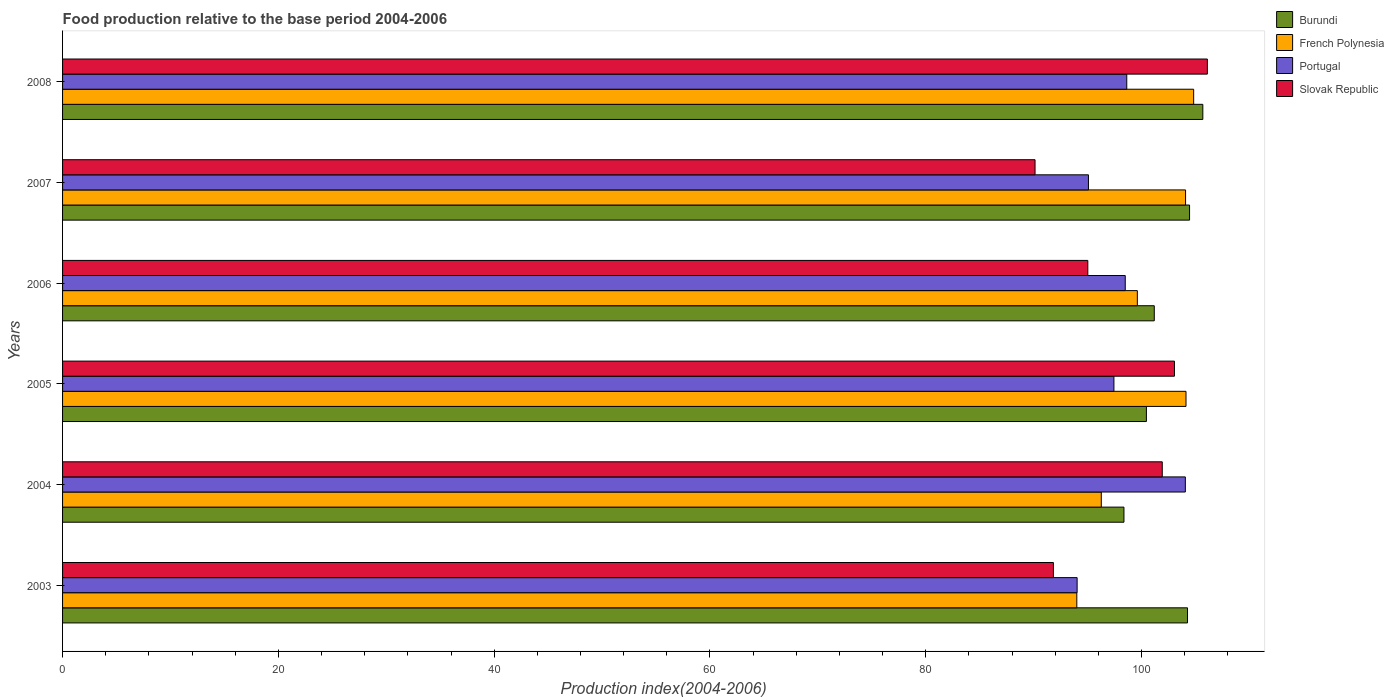Are the number of bars on each tick of the Y-axis equal?
Offer a very short reply. Yes. What is the food production index in Burundi in 2003?
Keep it short and to the point. 104.26. Across all years, what is the maximum food production index in Burundi?
Provide a short and direct response. 105.68. Across all years, what is the minimum food production index in French Polynesia?
Your answer should be very brief. 94. In which year was the food production index in Slovak Republic minimum?
Provide a succinct answer. 2007. What is the total food production index in Burundi in the graph?
Provide a short and direct response. 614.39. What is the difference between the food production index in Slovak Republic in 2004 and that in 2007?
Make the answer very short. 11.79. What is the difference between the food production index in Portugal in 2005 and the food production index in Slovak Republic in 2007?
Your answer should be very brief. 7.31. What is the average food production index in Slovak Republic per year?
Keep it short and to the point. 98.01. In the year 2007, what is the difference between the food production index in French Polynesia and food production index in Burundi?
Offer a very short reply. -0.37. In how many years, is the food production index in French Polynesia greater than 32 ?
Make the answer very short. 6. What is the ratio of the food production index in French Polynesia in 2004 to that in 2007?
Offer a very short reply. 0.92. Is the difference between the food production index in French Polynesia in 2007 and 2008 greater than the difference between the food production index in Burundi in 2007 and 2008?
Your response must be concise. Yes. What is the difference between the highest and the second highest food production index in Slovak Republic?
Your answer should be compact. 3.05. What is the difference between the highest and the lowest food production index in Slovak Republic?
Make the answer very short. 15.97. Is the sum of the food production index in Portugal in 2005 and 2008 greater than the maximum food production index in French Polynesia across all years?
Offer a terse response. Yes. What does the 3rd bar from the top in 2003 represents?
Keep it short and to the point. French Polynesia. What does the 4th bar from the bottom in 2008 represents?
Offer a very short reply. Slovak Republic. Are all the bars in the graph horizontal?
Make the answer very short. Yes. How many years are there in the graph?
Your answer should be compact. 6. What is the difference between two consecutive major ticks on the X-axis?
Your answer should be very brief. 20. Does the graph contain grids?
Your answer should be very brief. No. Where does the legend appear in the graph?
Offer a terse response. Top right. How many legend labels are there?
Your answer should be compact. 4. What is the title of the graph?
Your answer should be very brief. Food production relative to the base period 2004-2006. Does "Australia" appear as one of the legend labels in the graph?
Ensure brevity in your answer.  No. What is the label or title of the X-axis?
Your response must be concise. Production index(2004-2006). What is the Production index(2004-2006) of Burundi in 2003?
Your answer should be compact. 104.26. What is the Production index(2004-2006) of French Polynesia in 2003?
Offer a very short reply. 94. What is the Production index(2004-2006) in Portugal in 2003?
Provide a succinct answer. 94.03. What is the Production index(2004-2006) in Slovak Republic in 2003?
Your answer should be very brief. 91.83. What is the Production index(2004-2006) in Burundi in 2004?
Offer a very short reply. 98.37. What is the Production index(2004-2006) of French Polynesia in 2004?
Provide a succinct answer. 96.27. What is the Production index(2004-2006) in Portugal in 2004?
Make the answer very short. 104.06. What is the Production index(2004-2006) of Slovak Republic in 2004?
Your answer should be very brief. 101.92. What is the Production index(2004-2006) in Burundi in 2005?
Make the answer very short. 100.45. What is the Production index(2004-2006) of French Polynesia in 2005?
Make the answer very short. 104.12. What is the Production index(2004-2006) of Portugal in 2005?
Make the answer very short. 97.44. What is the Production index(2004-2006) in Slovak Republic in 2005?
Your answer should be compact. 103.05. What is the Production index(2004-2006) of Burundi in 2006?
Your answer should be compact. 101.18. What is the Production index(2004-2006) in French Polynesia in 2006?
Offer a very short reply. 99.61. What is the Production index(2004-2006) in Portugal in 2006?
Make the answer very short. 98.49. What is the Production index(2004-2006) of Slovak Republic in 2006?
Offer a terse response. 95.02. What is the Production index(2004-2006) of Burundi in 2007?
Give a very brief answer. 104.45. What is the Production index(2004-2006) in French Polynesia in 2007?
Provide a succinct answer. 104.08. What is the Production index(2004-2006) in Portugal in 2007?
Provide a short and direct response. 95.08. What is the Production index(2004-2006) of Slovak Republic in 2007?
Your answer should be very brief. 90.13. What is the Production index(2004-2006) of Burundi in 2008?
Give a very brief answer. 105.68. What is the Production index(2004-2006) in French Polynesia in 2008?
Offer a very short reply. 104.83. What is the Production index(2004-2006) of Portugal in 2008?
Keep it short and to the point. 98.63. What is the Production index(2004-2006) of Slovak Republic in 2008?
Offer a very short reply. 106.1. Across all years, what is the maximum Production index(2004-2006) in Burundi?
Give a very brief answer. 105.68. Across all years, what is the maximum Production index(2004-2006) in French Polynesia?
Give a very brief answer. 104.83. Across all years, what is the maximum Production index(2004-2006) in Portugal?
Provide a succinct answer. 104.06. Across all years, what is the maximum Production index(2004-2006) of Slovak Republic?
Your answer should be very brief. 106.1. Across all years, what is the minimum Production index(2004-2006) of Burundi?
Keep it short and to the point. 98.37. Across all years, what is the minimum Production index(2004-2006) of French Polynesia?
Provide a short and direct response. 94. Across all years, what is the minimum Production index(2004-2006) of Portugal?
Your answer should be very brief. 94.03. Across all years, what is the minimum Production index(2004-2006) of Slovak Republic?
Your answer should be compact. 90.13. What is the total Production index(2004-2006) in Burundi in the graph?
Your answer should be compact. 614.39. What is the total Production index(2004-2006) of French Polynesia in the graph?
Provide a short and direct response. 602.91. What is the total Production index(2004-2006) of Portugal in the graph?
Ensure brevity in your answer.  587.73. What is the total Production index(2004-2006) in Slovak Republic in the graph?
Offer a very short reply. 588.05. What is the difference between the Production index(2004-2006) in Burundi in 2003 and that in 2004?
Ensure brevity in your answer.  5.89. What is the difference between the Production index(2004-2006) of French Polynesia in 2003 and that in 2004?
Give a very brief answer. -2.27. What is the difference between the Production index(2004-2006) of Portugal in 2003 and that in 2004?
Ensure brevity in your answer.  -10.03. What is the difference between the Production index(2004-2006) in Slovak Republic in 2003 and that in 2004?
Ensure brevity in your answer.  -10.09. What is the difference between the Production index(2004-2006) in Burundi in 2003 and that in 2005?
Ensure brevity in your answer.  3.81. What is the difference between the Production index(2004-2006) of French Polynesia in 2003 and that in 2005?
Provide a short and direct response. -10.12. What is the difference between the Production index(2004-2006) in Portugal in 2003 and that in 2005?
Provide a short and direct response. -3.41. What is the difference between the Production index(2004-2006) of Slovak Republic in 2003 and that in 2005?
Your answer should be compact. -11.22. What is the difference between the Production index(2004-2006) in Burundi in 2003 and that in 2006?
Your answer should be compact. 3.08. What is the difference between the Production index(2004-2006) of French Polynesia in 2003 and that in 2006?
Provide a short and direct response. -5.61. What is the difference between the Production index(2004-2006) in Portugal in 2003 and that in 2006?
Your answer should be very brief. -4.46. What is the difference between the Production index(2004-2006) of Slovak Republic in 2003 and that in 2006?
Your answer should be very brief. -3.19. What is the difference between the Production index(2004-2006) in Burundi in 2003 and that in 2007?
Offer a terse response. -0.19. What is the difference between the Production index(2004-2006) of French Polynesia in 2003 and that in 2007?
Your answer should be compact. -10.08. What is the difference between the Production index(2004-2006) in Portugal in 2003 and that in 2007?
Make the answer very short. -1.05. What is the difference between the Production index(2004-2006) of Slovak Republic in 2003 and that in 2007?
Your answer should be compact. 1.7. What is the difference between the Production index(2004-2006) of Burundi in 2003 and that in 2008?
Your answer should be very brief. -1.42. What is the difference between the Production index(2004-2006) in French Polynesia in 2003 and that in 2008?
Keep it short and to the point. -10.83. What is the difference between the Production index(2004-2006) of Portugal in 2003 and that in 2008?
Give a very brief answer. -4.6. What is the difference between the Production index(2004-2006) in Slovak Republic in 2003 and that in 2008?
Make the answer very short. -14.27. What is the difference between the Production index(2004-2006) of Burundi in 2004 and that in 2005?
Ensure brevity in your answer.  -2.08. What is the difference between the Production index(2004-2006) in French Polynesia in 2004 and that in 2005?
Keep it short and to the point. -7.85. What is the difference between the Production index(2004-2006) of Portugal in 2004 and that in 2005?
Offer a very short reply. 6.62. What is the difference between the Production index(2004-2006) in Slovak Republic in 2004 and that in 2005?
Ensure brevity in your answer.  -1.13. What is the difference between the Production index(2004-2006) in Burundi in 2004 and that in 2006?
Your response must be concise. -2.81. What is the difference between the Production index(2004-2006) of French Polynesia in 2004 and that in 2006?
Provide a short and direct response. -3.34. What is the difference between the Production index(2004-2006) in Portugal in 2004 and that in 2006?
Your answer should be very brief. 5.57. What is the difference between the Production index(2004-2006) of Burundi in 2004 and that in 2007?
Your response must be concise. -6.08. What is the difference between the Production index(2004-2006) in French Polynesia in 2004 and that in 2007?
Keep it short and to the point. -7.81. What is the difference between the Production index(2004-2006) of Portugal in 2004 and that in 2007?
Offer a very short reply. 8.98. What is the difference between the Production index(2004-2006) in Slovak Republic in 2004 and that in 2007?
Give a very brief answer. 11.79. What is the difference between the Production index(2004-2006) of Burundi in 2004 and that in 2008?
Make the answer very short. -7.31. What is the difference between the Production index(2004-2006) in French Polynesia in 2004 and that in 2008?
Offer a very short reply. -8.56. What is the difference between the Production index(2004-2006) in Portugal in 2004 and that in 2008?
Offer a terse response. 5.43. What is the difference between the Production index(2004-2006) in Slovak Republic in 2004 and that in 2008?
Provide a short and direct response. -4.18. What is the difference between the Production index(2004-2006) in Burundi in 2005 and that in 2006?
Provide a succinct answer. -0.73. What is the difference between the Production index(2004-2006) in French Polynesia in 2005 and that in 2006?
Provide a short and direct response. 4.51. What is the difference between the Production index(2004-2006) in Portugal in 2005 and that in 2006?
Your response must be concise. -1.05. What is the difference between the Production index(2004-2006) of Slovak Republic in 2005 and that in 2006?
Ensure brevity in your answer.  8.03. What is the difference between the Production index(2004-2006) of Burundi in 2005 and that in 2007?
Give a very brief answer. -4. What is the difference between the Production index(2004-2006) of French Polynesia in 2005 and that in 2007?
Offer a terse response. 0.04. What is the difference between the Production index(2004-2006) in Portugal in 2005 and that in 2007?
Give a very brief answer. 2.36. What is the difference between the Production index(2004-2006) in Slovak Republic in 2005 and that in 2007?
Give a very brief answer. 12.92. What is the difference between the Production index(2004-2006) of Burundi in 2005 and that in 2008?
Ensure brevity in your answer.  -5.23. What is the difference between the Production index(2004-2006) of French Polynesia in 2005 and that in 2008?
Make the answer very short. -0.71. What is the difference between the Production index(2004-2006) in Portugal in 2005 and that in 2008?
Provide a short and direct response. -1.19. What is the difference between the Production index(2004-2006) in Slovak Republic in 2005 and that in 2008?
Keep it short and to the point. -3.05. What is the difference between the Production index(2004-2006) of Burundi in 2006 and that in 2007?
Your answer should be very brief. -3.27. What is the difference between the Production index(2004-2006) of French Polynesia in 2006 and that in 2007?
Your response must be concise. -4.47. What is the difference between the Production index(2004-2006) of Portugal in 2006 and that in 2007?
Offer a very short reply. 3.41. What is the difference between the Production index(2004-2006) in Slovak Republic in 2006 and that in 2007?
Ensure brevity in your answer.  4.89. What is the difference between the Production index(2004-2006) of French Polynesia in 2006 and that in 2008?
Your answer should be very brief. -5.22. What is the difference between the Production index(2004-2006) in Portugal in 2006 and that in 2008?
Offer a very short reply. -0.14. What is the difference between the Production index(2004-2006) of Slovak Republic in 2006 and that in 2008?
Make the answer very short. -11.08. What is the difference between the Production index(2004-2006) in Burundi in 2007 and that in 2008?
Make the answer very short. -1.23. What is the difference between the Production index(2004-2006) in French Polynesia in 2007 and that in 2008?
Your answer should be compact. -0.75. What is the difference between the Production index(2004-2006) of Portugal in 2007 and that in 2008?
Keep it short and to the point. -3.55. What is the difference between the Production index(2004-2006) in Slovak Republic in 2007 and that in 2008?
Provide a succinct answer. -15.97. What is the difference between the Production index(2004-2006) of Burundi in 2003 and the Production index(2004-2006) of French Polynesia in 2004?
Provide a short and direct response. 7.99. What is the difference between the Production index(2004-2006) in Burundi in 2003 and the Production index(2004-2006) in Slovak Republic in 2004?
Your answer should be compact. 2.34. What is the difference between the Production index(2004-2006) in French Polynesia in 2003 and the Production index(2004-2006) in Portugal in 2004?
Make the answer very short. -10.06. What is the difference between the Production index(2004-2006) of French Polynesia in 2003 and the Production index(2004-2006) of Slovak Republic in 2004?
Your answer should be compact. -7.92. What is the difference between the Production index(2004-2006) in Portugal in 2003 and the Production index(2004-2006) in Slovak Republic in 2004?
Offer a very short reply. -7.89. What is the difference between the Production index(2004-2006) of Burundi in 2003 and the Production index(2004-2006) of French Polynesia in 2005?
Your response must be concise. 0.14. What is the difference between the Production index(2004-2006) in Burundi in 2003 and the Production index(2004-2006) in Portugal in 2005?
Offer a terse response. 6.82. What is the difference between the Production index(2004-2006) in Burundi in 2003 and the Production index(2004-2006) in Slovak Republic in 2005?
Ensure brevity in your answer.  1.21. What is the difference between the Production index(2004-2006) in French Polynesia in 2003 and the Production index(2004-2006) in Portugal in 2005?
Keep it short and to the point. -3.44. What is the difference between the Production index(2004-2006) in French Polynesia in 2003 and the Production index(2004-2006) in Slovak Republic in 2005?
Your answer should be very brief. -9.05. What is the difference between the Production index(2004-2006) of Portugal in 2003 and the Production index(2004-2006) of Slovak Republic in 2005?
Your answer should be compact. -9.02. What is the difference between the Production index(2004-2006) of Burundi in 2003 and the Production index(2004-2006) of French Polynesia in 2006?
Offer a terse response. 4.65. What is the difference between the Production index(2004-2006) of Burundi in 2003 and the Production index(2004-2006) of Portugal in 2006?
Provide a succinct answer. 5.77. What is the difference between the Production index(2004-2006) in Burundi in 2003 and the Production index(2004-2006) in Slovak Republic in 2006?
Keep it short and to the point. 9.24. What is the difference between the Production index(2004-2006) of French Polynesia in 2003 and the Production index(2004-2006) of Portugal in 2006?
Keep it short and to the point. -4.49. What is the difference between the Production index(2004-2006) in French Polynesia in 2003 and the Production index(2004-2006) in Slovak Republic in 2006?
Provide a succinct answer. -1.02. What is the difference between the Production index(2004-2006) of Portugal in 2003 and the Production index(2004-2006) of Slovak Republic in 2006?
Make the answer very short. -0.99. What is the difference between the Production index(2004-2006) of Burundi in 2003 and the Production index(2004-2006) of French Polynesia in 2007?
Provide a succinct answer. 0.18. What is the difference between the Production index(2004-2006) of Burundi in 2003 and the Production index(2004-2006) of Portugal in 2007?
Ensure brevity in your answer.  9.18. What is the difference between the Production index(2004-2006) in Burundi in 2003 and the Production index(2004-2006) in Slovak Republic in 2007?
Offer a very short reply. 14.13. What is the difference between the Production index(2004-2006) of French Polynesia in 2003 and the Production index(2004-2006) of Portugal in 2007?
Keep it short and to the point. -1.08. What is the difference between the Production index(2004-2006) in French Polynesia in 2003 and the Production index(2004-2006) in Slovak Republic in 2007?
Make the answer very short. 3.87. What is the difference between the Production index(2004-2006) of Portugal in 2003 and the Production index(2004-2006) of Slovak Republic in 2007?
Ensure brevity in your answer.  3.9. What is the difference between the Production index(2004-2006) of Burundi in 2003 and the Production index(2004-2006) of French Polynesia in 2008?
Offer a terse response. -0.57. What is the difference between the Production index(2004-2006) of Burundi in 2003 and the Production index(2004-2006) of Portugal in 2008?
Keep it short and to the point. 5.63. What is the difference between the Production index(2004-2006) of Burundi in 2003 and the Production index(2004-2006) of Slovak Republic in 2008?
Keep it short and to the point. -1.84. What is the difference between the Production index(2004-2006) of French Polynesia in 2003 and the Production index(2004-2006) of Portugal in 2008?
Keep it short and to the point. -4.63. What is the difference between the Production index(2004-2006) of Portugal in 2003 and the Production index(2004-2006) of Slovak Republic in 2008?
Your answer should be compact. -12.07. What is the difference between the Production index(2004-2006) of Burundi in 2004 and the Production index(2004-2006) of French Polynesia in 2005?
Offer a very short reply. -5.75. What is the difference between the Production index(2004-2006) of Burundi in 2004 and the Production index(2004-2006) of Slovak Republic in 2005?
Ensure brevity in your answer.  -4.68. What is the difference between the Production index(2004-2006) of French Polynesia in 2004 and the Production index(2004-2006) of Portugal in 2005?
Your response must be concise. -1.17. What is the difference between the Production index(2004-2006) of French Polynesia in 2004 and the Production index(2004-2006) of Slovak Republic in 2005?
Provide a short and direct response. -6.78. What is the difference between the Production index(2004-2006) of Portugal in 2004 and the Production index(2004-2006) of Slovak Republic in 2005?
Your response must be concise. 1.01. What is the difference between the Production index(2004-2006) in Burundi in 2004 and the Production index(2004-2006) in French Polynesia in 2006?
Your response must be concise. -1.24. What is the difference between the Production index(2004-2006) of Burundi in 2004 and the Production index(2004-2006) of Portugal in 2006?
Your answer should be compact. -0.12. What is the difference between the Production index(2004-2006) of Burundi in 2004 and the Production index(2004-2006) of Slovak Republic in 2006?
Your answer should be very brief. 3.35. What is the difference between the Production index(2004-2006) of French Polynesia in 2004 and the Production index(2004-2006) of Portugal in 2006?
Make the answer very short. -2.22. What is the difference between the Production index(2004-2006) in Portugal in 2004 and the Production index(2004-2006) in Slovak Republic in 2006?
Offer a terse response. 9.04. What is the difference between the Production index(2004-2006) of Burundi in 2004 and the Production index(2004-2006) of French Polynesia in 2007?
Offer a terse response. -5.71. What is the difference between the Production index(2004-2006) of Burundi in 2004 and the Production index(2004-2006) of Portugal in 2007?
Make the answer very short. 3.29. What is the difference between the Production index(2004-2006) of Burundi in 2004 and the Production index(2004-2006) of Slovak Republic in 2007?
Provide a succinct answer. 8.24. What is the difference between the Production index(2004-2006) in French Polynesia in 2004 and the Production index(2004-2006) in Portugal in 2007?
Give a very brief answer. 1.19. What is the difference between the Production index(2004-2006) in French Polynesia in 2004 and the Production index(2004-2006) in Slovak Republic in 2007?
Make the answer very short. 6.14. What is the difference between the Production index(2004-2006) in Portugal in 2004 and the Production index(2004-2006) in Slovak Republic in 2007?
Offer a very short reply. 13.93. What is the difference between the Production index(2004-2006) in Burundi in 2004 and the Production index(2004-2006) in French Polynesia in 2008?
Provide a short and direct response. -6.46. What is the difference between the Production index(2004-2006) of Burundi in 2004 and the Production index(2004-2006) of Portugal in 2008?
Offer a very short reply. -0.26. What is the difference between the Production index(2004-2006) in Burundi in 2004 and the Production index(2004-2006) in Slovak Republic in 2008?
Offer a terse response. -7.73. What is the difference between the Production index(2004-2006) of French Polynesia in 2004 and the Production index(2004-2006) of Portugal in 2008?
Keep it short and to the point. -2.36. What is the difference between the Production index(2004-2006) in French Polynesia in 2004 and the Production index(2004-2006) in Slovak Republic in 2008?
Offer a very short reply. -9.83. What is the difference between the Production index(2004-2006) of Portugal in 2004 and the Production index(2004-2006) of Slovak Republic in 2008?
Keep it short and to the point. -2.04. What is the difference between the Production index(2004-2006) in Burundi in 2005 and the Production index(2004-2006) in French Polynesia in 2006?
Offer a terse response. 0.84. What is the difference between the Production index(2004-2006) in Burundi in 2005 and the Production index(2004-2006) in Portugal in 2006?
Provide a succinct answer. 1.96. What is the difference between the Production index(2004-2006) in Burundi in 2005 and the Production index(2004-2006) in Slovak Republic in 2006?
Your answer should be very brief. 5.43. What is the difference between the Production index(2004-2006) in French Polynesia in 2005 and the Production index(2004-2006) in Portugal in 2006?
Ensure brevity in your answer.  5.63. What is the difference between the Production index(2004-2006) of Portugal in 2005 and the Production index(2004-2006) of Slovak Republic in 2006?
Make the answer very short. 2.42. What is the difference between the Production index(2004-2006) in Burundi in 2005 and the Production index(2004-2006) in French Polynesia in 2007?
Offer a terse response. -3.63. What is the difference between the Production index(2004-2006) of Burundi in 2005 and the Production index(2004-2006) of Portugal in 2007?
Offer a terse response. 5.37. What is the difference between the Production index(2004-2006) in Burundi in 2005 and the Production index(2004-2006) in Slovak Republic in 2007?
Make the answer very short. 10.32. What is the difference between the Production index(2004-2006) of French Polynesia in 2005 and the Production index(2004-2006) of Portugal in 2007?
Your answer should be very brief. 9.04. What is the difference between the Production index(2004-2006) of French Polynesia in 2005 and the Production index(2004-2006) of Slovak Republic in 2007?
Make the answer very short. 13.99. What is the difference between the Production index(2004-2006) of Portugal in 2005 and the Production index(2004-2006) of Slovak Republic in 2007?
Keep it short and to the point. 7.31. What is the difference between the Production index(2004-2006) of Burundi in 2005 and the Production index(2004-2006) of French Polynesia in 2008?
Provide a succinct answer. -4.38. What is the difference between the Production index(2004-2006) in Burundi in 2005 and the Production index(2004-2006) in Portugal in 2008?
Provide a succinct answer. 1.82. What is the difference between the Production index(2004-2006) of Burundi in 2005 and the Production index(2004-2006) of Slovak Republic in 2008?
Your response must be concise. -5.65. What is the difference between the Production index(2004-2006) in French Polynesia in 2005 and the Production index(2004-2006) in Portugal in 2008?
Your response must be concise. 5.49. What is the difference between the Production index(2004-2006) in French Polynesia in 2005 and the Production index(2004-2006) in Slovak Republic in 2008?
Your answer should be compact. -1.98. What is the difference between the Production index(2004-2006) of Portugal in 2005 and the Production index(2004-2006) of Slovak Republic in 2008?
Offer a very short reply. -8.66. What is the difference between the Production index(2004-2006) in Burundi in 2006 and the Production index(2004-2006) in Slovak Republic in 2007?
Your response must be concise. 11.05. What is the difference between the Production index(2004-2006) in French Polynesia in 2006 and the Production index(2004-2006) in Portugal in 2007?
Your answer should be compact. 4.53. What is the difference between the Production index(2004-2006) of French Polynesia in 2006 and the Production index(2004-2006) of Slovak Republic in 2007?
Offer a very short reply. 9.48. What is the difference between the Production index(2004-2006) in Portugal in 2006 and the Production index(2004-2006) in Slovak Republic in 2007?
Your response must be concise. 8.36. What is the difference between the Production index(2004-2006) of Burundi in 2006 and the Production index(2004-2006) of French Polynesia in 2008?
Your answer should be compact. -3.65. What is the difference between the Production index(2004-2006) in Burundi in 2006 and the Production index(2004-2006) in Portugal in 2008?
Make the answer very short. 2.55. What is the difference between the Production index(2004-2006) of Burundi in 2006 and the Production index(2004-2006) of Slovak Republic in 2008?
Offer a terse response. -4.92. What is the difference between the Production index(2004-2006) in French Polynesia in 2006 and the Production index(2004-2006) in Portugal in 2008?
Offer a very short reply. 0.98. What is the difference between the Production index(2004-2006) of French Polynesia in 2006 and the Production index(2004-2006) of Slovak Republic in 2008?
Make the answer very short. -6.49. What is the difference between the Production index(2004-2006) of Portugal in 2006 and the Production index(2004-2006) of Slovak Republic in 2008?
Your answer should be compact. -7.61. What is the difference between the Production index(2004-2006) of Burundi in 2007 and the Production index(2004-2006) of French Polynesia in 2008?
Your response must be concise. -0.38. What is the difference between the Production index(2004-2006) in Burundi in 2007 and the Production index(2004-2006) in Portugal in 2008?
Keep it short and to the point. 5.82. What is the difference between the Production index(2004-2006) of Burundi in 2007 and the Production index(2004-2006) of Slovak Republic in 2008?
Keep it short and to the point. -1.65. What is the difference between the Production index(2004-2006) of French Polynesia in 2007 and the Production index(2004-2006) of Portugal in 2008?
Your answer should be very brief. 5.45. What is the difference between the Production index(2004-2006) of French Polynesia in 2007 and the Production index(2004-2006) of Slovak Republic in 2008?
Your answer should be compact. -2.02. What is the difference between the Production index(2004-2006) of Portugal in 2007 and the Production index(2004-2006) of Slovak Republic in 2008?
Ensure brevity in your answer.  -11.02. What is the average Production index(2004-2006) of Burundi per year?
Make the answer very short. 102.4. What is the average Production index(2004-2006) of French Polynesia per year?
Your answer should be very brief. 100.48. What is the average Production index(2004-2006) in Portugal per year?
Offer a terse response. 97.95. What is the average Production index(2004-2006) in Slovak Republic per year?
Keep it short and to the point. 98.01. In the year 2003, what is the difference between the Production index(2004-2006) of Burundi and Production index(2004-2006) of French Polynesia?
Provide a short and direct response. 10.26. In the year 2003, what is the difference between the Production index(2004-2006) of Burundi and Production index(2004-2006) of Portugal?
Provide a short and direct response. 10.23. In the year 2003, what is the difference between the Production index(2004-2006) in Burundi and Production index(2004-2006) in Slovak Republic?
Make the answer very short. 12.43. In the year 2003, what is the difference between the Production index(2004-2006) of French Polynesia and Production index(2004-2006) of Portugal?
Ensure brevity in your answer.  -0.03. In the year 2003, what is the difference between the Production index(2004-2006) of French Polynesia and Production index(2004-2006) of Slovak Republic?
Your answer should be compact. 2.17. In the year 2004, what is the difference between the Production index(2004-2006) in Burundi and Production index(2004-2006) in Portugal?
Provide a short and direct response. -5.69. In the year 2004, what is the difference between the Production index(2004-2006) of Burundi and Production index(2004-2006) of Slovak Republic?
Offer a terse response. -3.55. In the year 2004, what is the difference between the Production index(2004-2006) of French Polynesia and Production index(2004-2006) of Portugal?
Your answer should be compact. -7.79. In the year 2004, what is the difference between the Production index(2004-2006) of French Polynesia and Production index(2004-2006) of Slovak Republic?
Your answer should be compact. -5.65. In the year 2004, what is the difference between the Production index(2004-2006) in Portugal and Production index(2004-2006) in Slovak Republic?
Your answer should be compact. 2.14. In the year 2005, what is the difference between the Production index(2004-2006) of Burundi and Production index(2004-2006) of French Polynesia?
Offer a very short reply. -3.67. In the year 2005, what is the difference between the Production index(2004-2006) of Burundi and Production index(2004-2006) of Portugal?
Provide a succinct answer. 3.01. In the year 2005, what is the difference between the Production index(2004-2006) of Burundi and Production index(2004-2006) of Slovak Republic?
Make the answer very short. -2.6. In the year 2005, what is the difference between the Production index(2004-2006) of French Polynesia and Production index(2004-2006) of Portugal?
Provide a short and direct response. 6.68. In the year 2005, what is the difference between the Production index(2004-2006) of French Polynesia and Production index(2004-2006) of Slovak Republic?
Ensure brevity in your answer.  1.07. In the year 2005, what is the difference between the Production index(2004-2006) in Portugal and Production index(2004-2006) in Slovak Republic?
Your answer should be compact. -5.61. In the year 2006, what is the difference between the Production index(2004-2006) in Burundi and Production index(2004-2006) in French Polynesia?
Keep it short and to the point. 1.57. In the year 2006, what is the difference between the Production index(2004-2006) in Burundi and Production index(2004-2006) in Portugal?
Give a very brief answer. 2.69. In the year 2006, what is the difference between the Production index(2004-2006) in Burundi and Production index(2004-2006) in Slovak Republic?
Ensure brevity in your answer.  6.16. In the year 2006, what is the difference between the Production index(2004-2006) in French Polynesia and Production index(2004-2006) in Portugal?
Your response must be concise. 1.12. In the year 2006, what is the difference between the Production index(2004-2006) of French Polynesia and Production index(2004-2006) of Slovak Republic?
Give a very brief answer. 4.59. In the year 2006, what is the difference between the Production index(2004-2006) of Portugal and Production index(2004-2006) of Slovak Republic?
Offer a terse response. 3.47. In the year 2007, what is the difference between the Production index(2004-2006) of Burundi and Production index(2004-2006) of French Polynesia?
Provide a succinct answer. 0.37. In the year 2007, what is the difference between the Production index(2004-2006) of Burundi and Production index(2004-2006) of Portugal?
Provide a succinct answer. 9.37. In the year 2007, what is the difference between the Production index(2004-2006) of Burundi and Production index(2004-2006) of Slovak Republic?
Provide a short and direct response. 14.32. In the year 2007, what is the difference between the Production index(2004-2006) of French Polynesia and Production index(2004-2006) of Portugal?
Make the answer very short. 9. In the year 2007, what is the difference between the Production index(2004-2006) in French Polynesia and Production index(2004-2006) in Slovak Republic?
Make the answer very short. 13.95. In the year 2007, what is the difference between the Production index(2004-2006) of Portugal and Production index(2004-2006) of Slovak Republic?
Make the answer very short. 4.95. In the year 2008, what is the difference between the Production index(2004-2006) in Burundi and Production index(2004-2006) in French Polynesia?
Provide a short and direct response. 0.85. In the year 2008, what is the difference between the Production index(2004-2006) in Burundi and Production index(2004-2006) in Portugal?
Provide a short and direct response. 7.05. In the year 2008, what is the difference between the Production index(2004-2006) of Burundi and Production index(2004-2006) of Slovak Republic?
Make the answer very short. -0.42. In the year 2008, what is the difference between the Production index(2004-2006) in French Polynesia and Production index(2004-2006) in Slovak Republic?
Provide a short and direct response. -1.27. In the year 2008, what is the difference between the Production index(2004-2006) of Portugal and Production index(2004-2006) of Slovak Republic?
Your answer should be very brief. -7.47. What is the ratio of the Production index(2004-2006) of Burundi in 2003 to that in 2004?
Provide a succinct answer. 1.06. What is the ratio of the Production index(2004-2006) in French Polynesia in 2003 to that in 2004?
Keep it short and to the point. 0.98. What is the ratio of the Production index(2004-2006) in Portugal in 2003 to that in 2004?
Your answer should be very brief. 0.9. What is the ratio of the Production index(2004-2006) of Slovak Republic in 2003 to that in 2004?
Ensure brevity in your answer.  0.9. What is the ratio of the Production index(2004-2006) in Burundi in 2003 to that in 2005?
Your response must be concise. 1.04. What is the ratio of the Production index(2004-2006) of French Polynesia in 2003 to that in 2005?
Your answer should be compact. 0.9. What is the ratio of the Production index(2004-2006) of Slovak Republic in 2003 to that in 2005?
Your answer should be very brief. 0.89. What is the ratio of the Production index(2004-2006) in Burundi in 2003 to that in 2006?
Make the answer very short. 1.03. What is the ratio of the Production index(2004-2006) of French Polynesia in 2003 to that in 2006?
Give a very brief answer. 0.94. What is the ratio of the Production index(2004-2006) in Portugal in 2003 to that in 2006?
Keep it short and to the point. 0.95. What is the ratio of the Production index(2004-2006) in Slovak Republic in 2003 to that in 2006?
Your answer should be very brief. 0.97. What is the ratio of the Production index(2004-2006) of French Polynesia in 2003 to that in 2007?
Your answer should be compact. 0.9. What is the ratio of the Production index(2004-2006) of Portugal in 2003 to that in 2007?
Provide a succinct answer. 0.99. What is the ratio of the Production index(2004-2006) in Slovak Republic in 2003 to that in 2007?
Ensure brevity in your answer.  1.02. What is the ratio of the Production index(2004-2006) in Burundi in 2003 to that in 2008?
Ensure brevity in your answer.  0.99. What is the ratio of the Production index(2004-2006) in French Polynesia in 2003 to that in 2008?
Your answer should be very brief. 0.9. What is the ratio of the Production index(2004-2006) in Portugal in 2003 to that in 2008?
Give a very brief answer. 0.95. What is the ratio of the Production index(2004-2006) in Slovak Republic in 2003 to that in 2008?
Your answer should be very brief. 0.87. What is the ratio of the Production index(2004-2006) in Burundi in 2004 to that in 2005?
Give a very brief answer. 0.98. What is the ratio of the Production index(2004-2006) of French Polynesia in 2004 to that in 2005?
Offer a very short reply. 0.92. What is the ratio of the Production index(2004-2006) in Portugal in 2004 to that in 2005?
Your answer should be very brief. 1.07. What is the ratio of the Production index(2004-2006) of Burundi in 2004 to that in 2006?
Your answer should be very brief. 0.97. What is the ratio of the Production index(2004-2006) in French Polynesia in 2004 to that in 2006?
Make the answer very short. 0.97. What is the ratio of the Production index(2004-2006) in Portugal in 2004 to that in 2006?
Give a very brief answer. 1.06. What is the ratio of the Production index(2004-2006) of Slovak Republic in 2004 to that in 2006?
Your answer should be very brief. 1.07. What is the ratio of the Production index(2004-2006) of Burundi in 2004 to that in 2007?
Give a very brief answer. 0.94. What is the ratio of the Production index(2004-2006) of French Polynesia in 2004 to that in 2007?
Keep it short and to the point. 0.93. What is the ratio of the Production index(2004-2006) in Portugal in 2004 to that in 2007?
Offer a terse response. 1.09. What is the ratio of the Production index(2004-2006) in Slovak Republic in 2004 to that in 2007?
Give a very brief answer. 1.13. What is the ratio of the Production index(2004-2006) in Burundi in 2004 to that in 2008?
Keep it short and to the point. 0.93. What is the ratio of the Production index(2004-2006) of French Polynesia in 2004 to that in 2008?
Your answer should be very brief. 0.92. What is the ratio of the Production index(2004-2006) of Portugal in 2004 to that in 2008?
Provide a succinct answer. 1.06. What is the ratio of the Production index(2004-2006) in Slovak Republic in 2004 to that in 2008?
Your response must be concise. 0.96. What is the ratio of the Production index(2004-2006) in Burundi in 2005 to that in 2006?
Offer a very short reply. 0.99. What is the ratio of the Production index(2004-2006) in French Polynesia in 2005 to that in 2006?
Your answer should be very brief. 1.05. What is the ratio of the Production index(2004-2006) in Portugal in 2005 to that in 2006?
Provide a succinct answer. 0.99. What is the ratio of the Production index(2004-2006) in Slovak Republic in 2005 to that in 2006?
Offer a very short reply. 1.08. What is the ratio of the Production index(2004-2006) in Burundi in 2005 to that in 2007?
Make the answer very short. 0.96. What is the ratio of the Production index(2004-2006) of French Polynesia in 2005 to that in 2007?
Make the answer very short. 1. What is the ratio of the Production index(2004-2006) in Portugal in 2005 to that in 2007?
Give a very brief answer. 1.02. What is the ratio of the Production index(2004-2006) of Slovak Republic in 2005 to that in 2007?
Give a very brief answer. 1.14. What is the ratio of the Production index(2004-2006) of Burundi in 2005 to that in 2008?
Your response must be concise. 0.95. What is the ratio of the Production index(2004-2006) in French Polynesia in 2005 to that in 2008?
Give a very brief answer. 0.99. What is the ratio of the Production index(2004-2006) of Portugal in 2005 to that in 2008?
Provide a succinct answer. 0.99. What is the ratio of the Production index(2004-2006) of Slovak Republic in 2005 to that in 2008?
Provide a short and direct response. 0.97. What is the ratio of the Production index(2004-2006) of Burundi in 2006 to that in 2007?
Your answer should be very brief. 0.97. What is the ratio of the Production index(2004-2006) of French Polynesia in 2006 to that in 2007?
Your response must be concise. 0.96. What is the ratio of the Production index(2004-2006) in Portugal in 2006 to that in 2007?
Offer a very short reply. 1.04. What is the ratio of the Production index(2004-2006) of Slovak Republic in 2006 to that in 2007?
Give a very brief answer. 1.05. What is the ratio of the Production index(2004-2006) of Burundi in 2006 to that in 2008?
Give a very brief answer. 0.96. What is the ratio of the Production index(2004-2006) of French Polynesia in 2006 to that in 2008?
Your answer should be compact. 0.95. What is the ratio of the Production index(2004-2006) in Slovak Republic in 2006 to that in 2008?
Make the answer very short. 0.9. What is the ratio of the Production index(2004-2006) of Burundi in 2007 to that in 2008?
Keep it short and to the point. 0.99. What is the ratio of the Production index(2004-2006) of French Polynesia in 2007 to that in 2008?
Your answer should be compact. 0.99. What is the ratio of the Production index(2004-2006) in Portugal in 2007 to that in 2008?
Make the answer very short. 0.96. What is the ratio of the Production index(2004-2006) of Slovak Republic in 2007 to that in 2008?
Provide a succinct answer. 0.85. What is the difference between the highest and the second highest Production index(2004-2006) of Burundi?
Give a very brief answer. 1.23. What is the difference between the highest and the second highest Production index(2004-2006) of French Polynesia?
Give a very brief answer. 0.71. What is the difference between the highest and the second highest Production index(2004-2006) of Portugal?
Ensure brevity in your answer.  5.43. What is the difference between the highest and the second highest Production index(2004-2006) in Slovak Republic?
Give a very brief answer. 3.05. What is the difference between the highest and the lowest Production index(2004-2006) of Burundi?
Your answer should be very brief. 7.31. What is the difference between the highest and the lowest Production index(2004-2006) in French Polynesia?
Make the answer very short. 10.83. What is the difference between the highest and the lowest Production index(2004-2006) of Portugal?
Your answer should be very brief. 10.03. What is the difference between the highest and the lowest Production index(2004-2006) of Slovak Republic?
Your response must be concise. 15.97. 